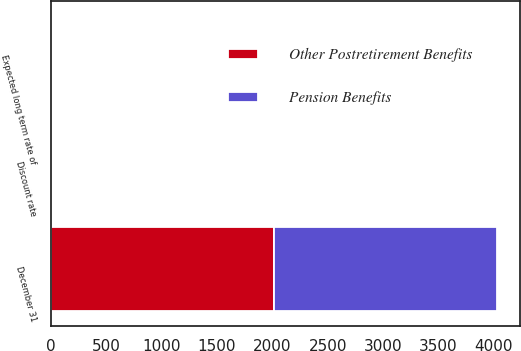<chart> <loc_0><loc_0><loc_500><loc_500><stacked_bar_chart><ecel><fcel>December 31<fcel>Discount rate<fcel>Expected long term rate of<nl><fcel>Pension Benefits<fcel>2016<fcel>3.9<fcel>7.5<nl><fcel>Other Postretirement Benefits<fcel>2016<fcel>3.7<fcel>5.3<nl></chart> 